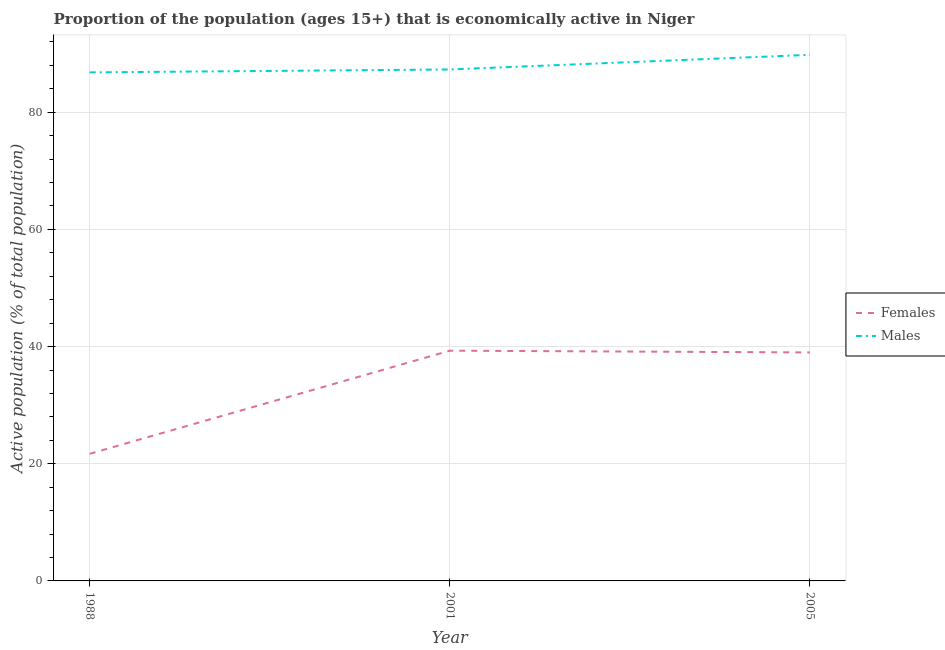How many different coloured lines are there?
Your answer should be compact. 2. Is the number of lines equal to the number of legend labels?
Keep it short and to the point. Yes. What is the percentage of economically active female population in 2001?
Make the answer very short. 39.3. Across all years, what is the maximum percentage of economically active male population?
Your answer should be very brief. 89.8. Across all years, what is the minimum percentage of economically active female population?
Provide a succinct answer. 21.7. In which year was the percentage of economically active female population maximum?
Your answer should be very brief. 2001. In which year was the percentage of economically active male population minimum?
Your answer should be compact. 1988. What is the total percentage of economically active male population in the graph?
Make the answer very short. 263.9. What is the difference between the percentage of economically active male population in 1988 and that in 2001?
Provide a succinct answer. -0.5. What is the difference between the percentage of economically active male population in 1988 and the percentage of economically active female population in 2001?
Ensure brevity in your answer.  47.5. What is the average percentage of economically active male population per year?
Provide a succinct answer. 87.97. In the year 1988, what is the difference between the percentage of economically active female population and percentage of economically active male population?
Your response must be concise. -65.1. In how many years, is the percentage of economically active female population greater than 72 %?
Your answer should be very brief. 0. What is the ratio of the percentage of economically active male population in 1988 to that in 2005?
Provide a succinct answer. 0.97. Is the difference between the percentage of economically active female population in 2001 and 2005 greater than the difference between the percentage of economically active male population in 2001 and 2005?
Offer a terse response. Yes. What is the difference between the highest and the lowest percentage of economically active male population?
Ensure brevity in your answer.  3. In how many years, is the percentage of economically active male population greater than the average percentage of economically active male population taken over all years?
Offer a very short reply. 1. Is the sum of the percentage of economically active male population in 1988 and 2001 greater than the maximum percentage of economically active female population across all years?
Provide a short and direct response. Yes. Does the percentage of economically active female population monotonically increase over the years?
Give a very brief answer. No. Is the percentage of economically active male population strictly greater than the percentage of economically active female population over the years?
Provide a short and direct response. Yes. Is the percentage of economically active female population strictly less than the percentage of economically active male population over the years?
Offer a very short reply. Yes. How many lines are there?
Ensure brevity in your answer.  2. Does the graph contain grids?
Offer a terse response. Yes. Where does the legend appear in the graph?
Your response must be concise. Center right. How are the legend labels stacked?
Your answer should be very brief. Vertical. What is the title of the graph?
Provide a short and direct response. Proportion of the population (ages 15+) that is economically active in Niger. What is the label or title of the X-axis?
Offer a terse response. Year. What is the label or title of the Y-axis?
Offer a very short reply. Active population (% of total population). What is the Active population (% of total population) in Females in 1988?
Offer a very short reply. 21.7. What is the Active population (% of total population) in Males in 1988?
Keep it short and to the point. 86.8. What is the Active population (% of total population) in Females in 2001?
Your answer should be compact. 39.3. What is the Active population (% of total population) of Males in 2001?
Give a very brief answer. 87.3. What is the Active population (% of total population) of Females in 2005?
Offer a very short reply. 39. What is the Active population (% of total population) of Males in 2005?
Your answer should be compact. 89.8. Across all years, what is the maximum Active population (% of total population) in Females?
Provide a succinct answer. 39.3. Across all years, what is the maximum Active population (% of total population) of Males?
Make the answer very short. 89.8. Across all years, what is the minimum Active population (% of total population) in Females?
Your response must be concise. 21.7. Across all years, what is the minimum Active population (% of total population) in Males?
Make the answer very short. 86.8. What is the total Active population (% of total population) in Females in the graph?
Your answer should be very brief. 100. What is the total Active population (% of total population) of Males in the graph?
Your answer should be very brief. 263.9. What is the difference between the Active population (% of total population) in Females in 1988 and that in 2001?
Ensure brevity in your answer.  -17.6. What is the difference between the Active population (% of total population) in Males in 1988 and that in 2001?
Give a very brief answer. -0.5. What is the difference between the Active population (% of total population) in Females in 1988 and that in 2005?
Your response must be concise. -17.3. What is the difference between the Active population (% of total population) in Females in 2001 and that in 2005?
Your response must be concise. 0.3. What is the difference between the Active population (% of total population) of Males in 2001 and that in 2005?
Make the answer very short. -2.5. What is the difference between the Active population (% of total population) in Females in 1988 and the Active population (% of total population) in Males in 2001?
Offer a very short reply. -65.6. What is the difference between the Active population (% of total population) of Females in 1988 and the Active population (% of total population) of Males in 2005?
Keep it short and to the point. -68.1. What is the difference between the Active population (% of total population) of Females in 2001 and the Active population (% of total population) of Males in 2005?
Your answer should be compact. -50.5. What is the average Active population (% of total population) of Females per year?
Your response must be concise. 33.33. What is the average Active population (% of total population) of Males per year?
Offer a terse response. 87.97. In the year 1988, what is the difference between the Active population (% of total population) of Females and Active population (% of total population) of Males?
Ensure brevity in your answer.  -65.1. In the year 2001, what is the difference between the Active population (% of total population) in Females and Active population (% of total population) in Males?
Offer a very short reply. -48. In the year 2005, what is the difference between the Active population (% of total population) in Females and Active population (% of total population) in Males?
Offer a terse response. -50.8. What is the ratio of the Active population (% of total population) of Females in 1988 to that in 2001?
Offer a terse response. 0.55. What is the ratio of the Active population (% of total population) in Males in 1988 to that in 2001?
Offer a terse response. 0.99. What is the ratio of the Active population (% of total population) of Females in 1988 to that in 2005?
Your answer should be compact. 0.56. What is the ratio of the Active population (% of total population) in Males in 1988 to that in 2005?
Ensure brevity in your answer.  0.97. What is the ratio of the Active population (% of total population) of Females in 2001 to that in 2005?
Give a very brief answer. 1.01. What is the ratio of the Active population (% of total population) of Males in 2001 to that in 2005?
Make the answer very short. 0.97. What is the difference between the highest and the second highest Active population (% of total population) of Females?
Your answer should be compact. 0.3. What is the difference between the highest and the lowest Active population (% of total population) of Males?
Keep it short and to the point. 3. 